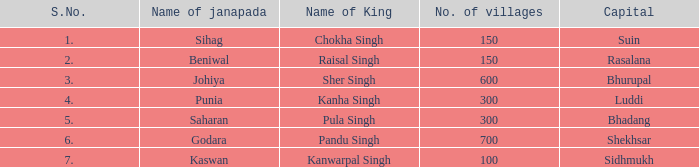Would you mind parsing the complete table? {'header': ['S.No.', 'Name of janapada', 'Name of King', 'No. of villages', 'Capital'], 'rows': [['1.', 'Sihag', 'Chokha Singh', '150', 'Suin'], ['2.', 'Beniwal', 'Raisal Singh', '150', 'Rasalana'], ['3.', 'Johiya', 'Sher Singh', '600', 'Bhurupal'], ['4.', 'Punia', 'Kanha Singh', '300', 'Luddi'], ['5.', 'Saharan', 'Pula Singh', '300', 'Bhadang'], ['6.', 'Godara', 'Pandu Singh', '700', 'Shekhsar'], ['7.', 'Kaswan', 'Kanwarpal Singh', '100', 'Sidhmukh']]} What is the average number of villages with a name of janapada of Punia? 300.0. 